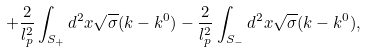<formula> <loc_0><loc_0><loc_500><loc_500>+ \frac { 2 } { l _ { p } ^ { 2 } } \int _ { S _ { + } } d ^ { 2 } x \sqrt { \sigma } ( k - k ^ { 0 } ) - \frac { 2 } { l _ { p } ^ { 2 } } \int _ { S _ { - } } d ^ { 2 } x \sqrt { \sigma } ( k - k ^ { 0 } ) ,</formula> 